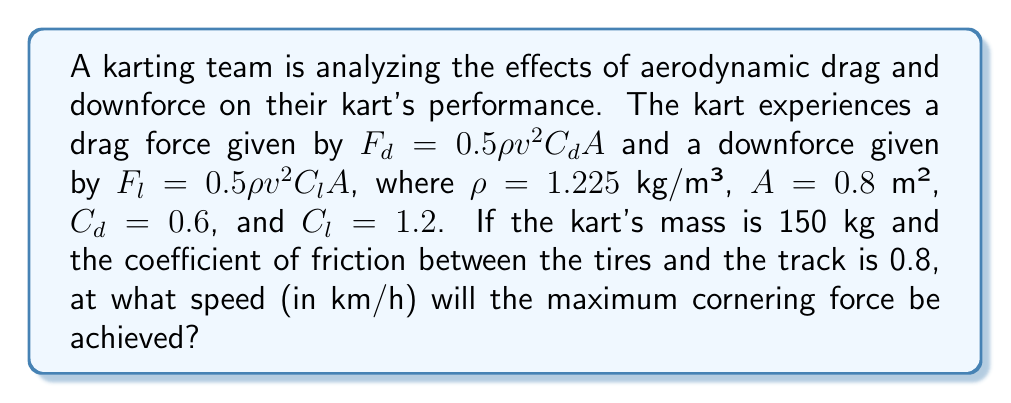Teach me how to tackle this problem. To solve this problem, we need to follow these steps:

1) The cornering force is limited by friction, which depends on the normal force on the tires. This normal force is the sum of the kart's weight and the downforce:

   $F_N = mg + F_l$

2) The maximum cornering force is then:

   $F_c = \mu F_N = \mu(mg + F_l)$

3) Substitute the downforce equation:

   $F_c = \mu(mg + 0.5\rho v^2 C_l A)$

4) The maximum cornering force occurs when the increase in downforce is balanced by the increase in drag. At this point, the derivative of $F_c$ with respect to $v$ equals zero:

   $\frac{d}{dv}F_c = \frac{d}{dv}[\mu(mg + 0.5\rho v^2 C_l A)] = 0$

5) Solving this equation:

   $\mu \rho v C_l A = 0$

6) This is always true when $v = 0$, but we're interested in the non-zero solution. The other way this equation can be true is if $\mu = 0$, which occurs when the drag force equals the cornering force:

   $F_d = F_c$

7) Expand this equation:

   $0.5\rho v^2 C_d A = \mu(mg + 0.5\rho v^2 C_l A)$

8) Solve for $v$:

   $$v = \sqrt{\frac{2\mu mg}{\rho A(C_d - \mu C_l)}}$$

9) Now substitute the given values:

   $v = \sqrt{\frac{2 * 0.8 * 150 * 9.81}{1.225 * 0.8(0.6 - 0.8 * 1.2)}} = 27.86$ m/s

10) Convert to km/h:

    $27.86 * 3.6 = 100.3$ km/h
Answer: 100.3 km/h 